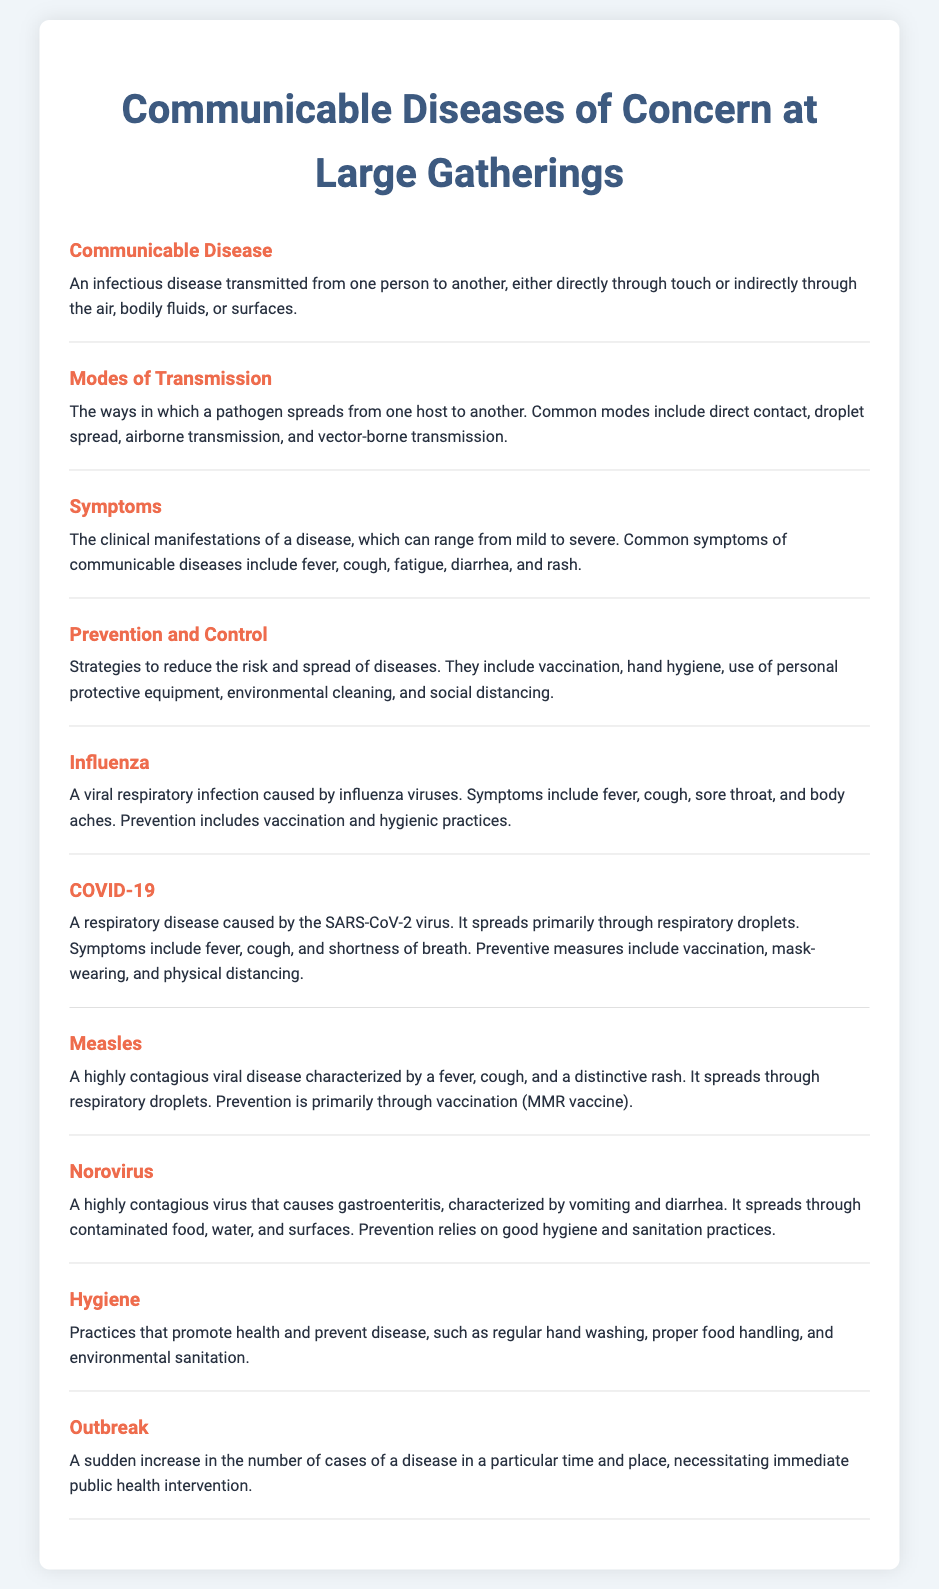What is a communicable disease? A communicable disease is defined in the document as an infectious disease transmitted from one person to another, either directly through touch or indirectly through the air, bodily fluids, or surfaces.
Answer: An infectious disease transmitted from one person to another What are the common modes of transmission? The document lists modes of transmission as ways a pathogen spreads, including direct contact, droplet spread, airborne transmission, and vector-borne transmission.
Answer: Direct contact, droplet spread, airborne transmission, and vector-borne transmission What symptoms are associated with communicable diseases? The document describes symptoms of communicable diseases, which include fever, cough, fatigue, diarrhea, and rash.
Answer: Fever, cough, fatigue, diarrhea, and rash What is one preventive measure against COVID-19? The document outlines preventive measures for COVID-19, specifically noting that vaccination is a key strategy, alongside mask-wearing and physical distancing.
Answer: Vaccination How is measles primarily prevented? The document notes that prevention of measles is primarily through vaccination, particularly the MMR vaccine.
Answer: Vaccination (MMR vaccine) What is an outbreak? An outbreak is described in the document as a sudden increase in the number of cases of a disease in a particular time and place, necessitating immediate public health intervention.
Answer: A sudden increase in the number of cases of a disease What does hygiene promote? The document defines hygiene practices as promoting health and preventing disease.
Answer: Health and preventing disease Name a symptom of norovirus. The document lists symptoms of norovirus as characterized by vomiting and diarrhea.
Answer: Vomiting and diarrhea 